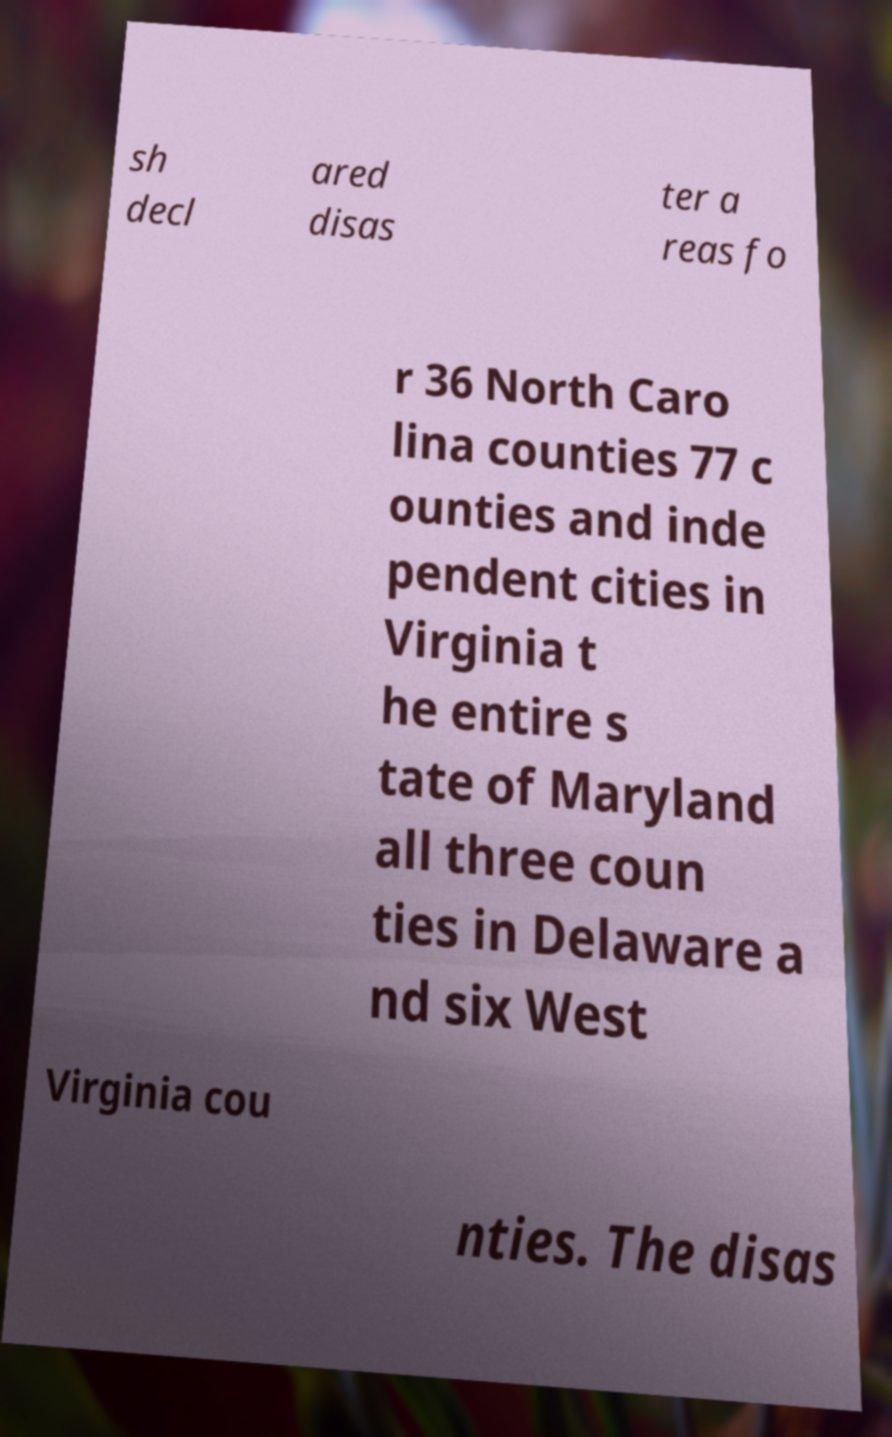Can you read and provide the text displayed in the image?This photo seems to have some interesting text. Can you extract and type it out for me? sh decl ared disas ter a reas fo r 36 North Caro lina counties 77 c ounties and inde pendent cities in Virginia t he entire s tate of Maryland all three coun ties in Delaware a nd six West Virginia cou nties. The disas 